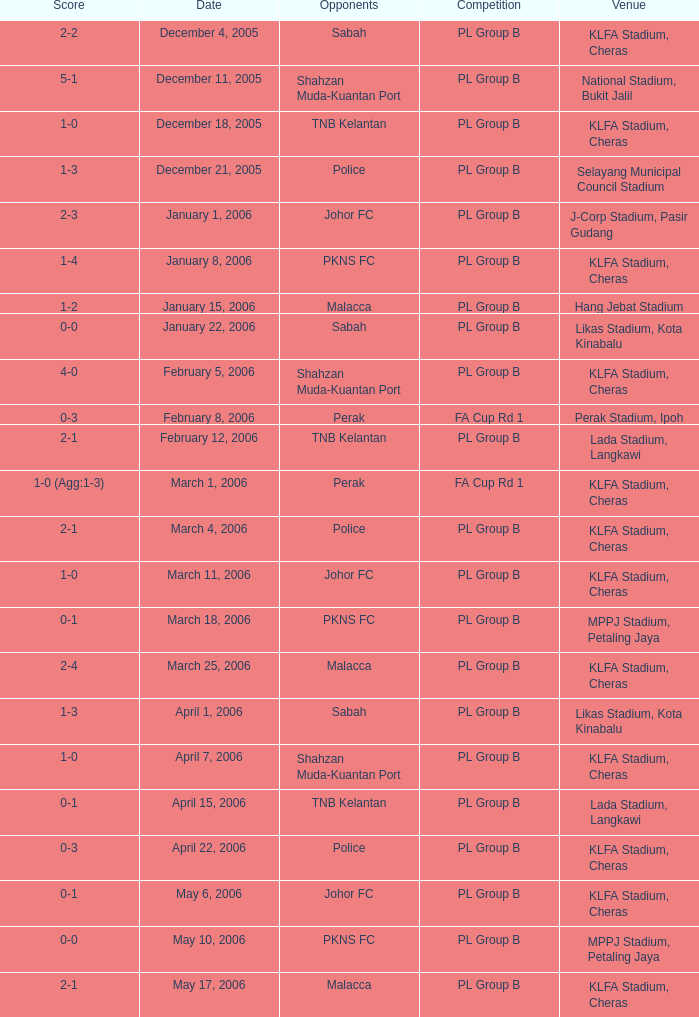Which Date has a Competition of pl group b, and Opponents of police, and a Venue of selayang municipal council stadium? December 21, 2005. 